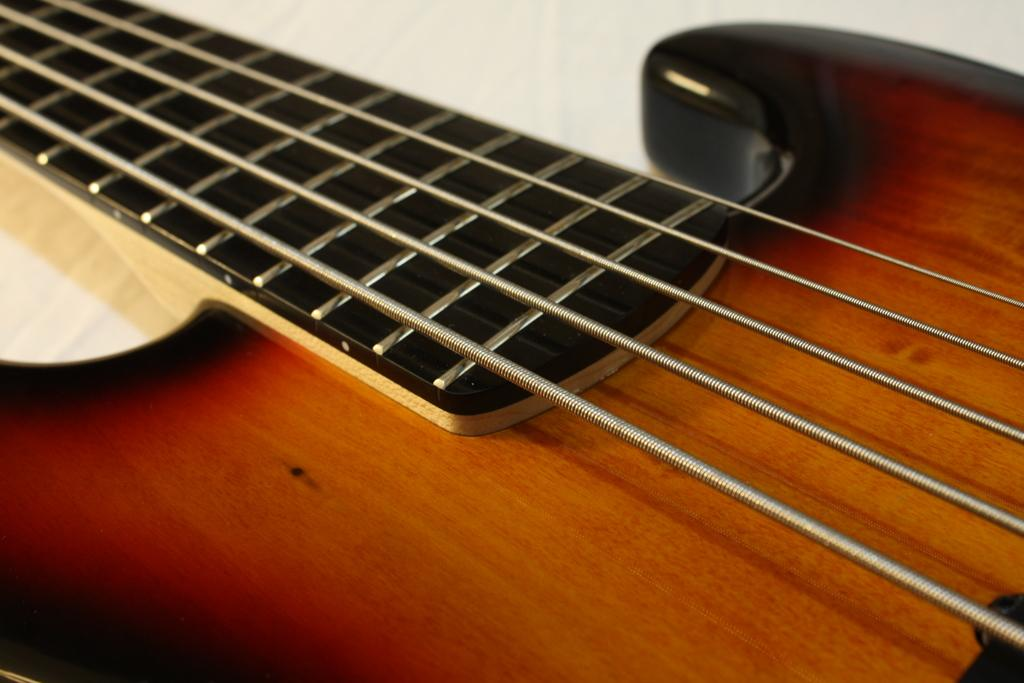What musical instrument can be seen in the image? There is a guitar present in the image. What feature of the guitar is visible in the image? The guitar has visible strings. Where is the guitar placed in the image? The guitar is placed on a table or the floor. What type of lace is being used to hold the guitar in the image? There is no lace present in the image; the guitar is simply placed on a table or the floor. 